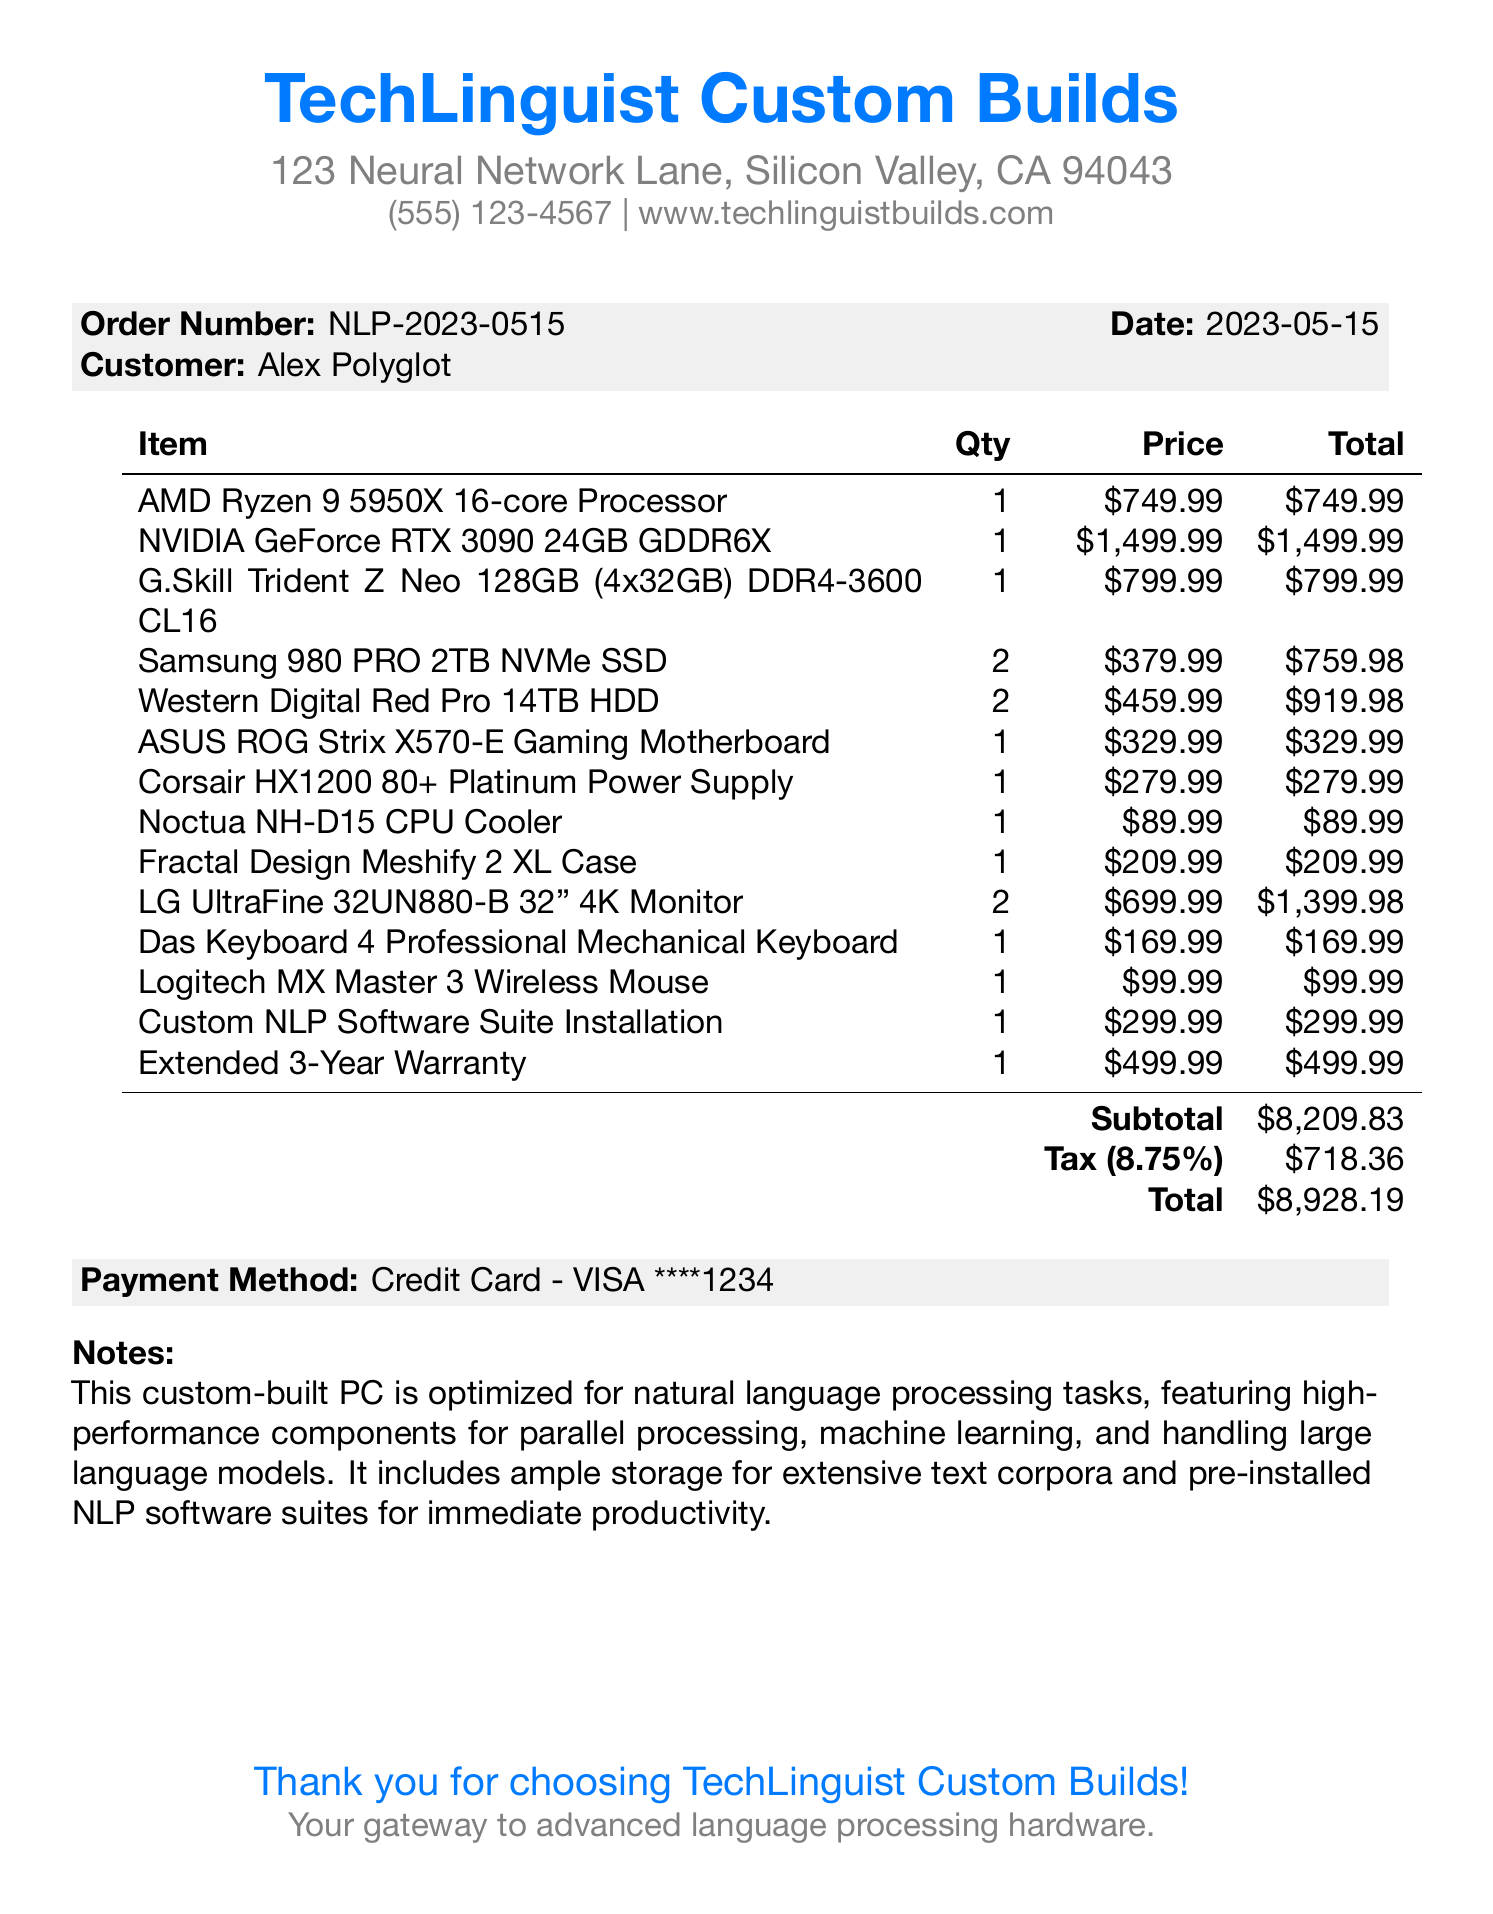What is the name of the store? The store name is listed at the top of the receipt.
Answer: TechLinguist Custom Builds What is the order number? The order number is mentioned in the order details section of the receipt.
Answer: NLP-2023-0515 How much did the AMD Ryzen 9 5950X cost? The price of the AMD Ryzen 9 5950X is specified in the item list.
Answer: $749.99 What is the quantity of NVIDIA GeForce RTX 3090 purchased? The quantity is indicated in the item list of the receipt.
Answer: 1 What is the total amount for the extended warranty? The total amount is included in the final totals section of the receipt.
Answer: $499.99 What is the total tax amount? The total tax amount is calculated based on the subtotal and tax rate provided.
Answer: $718.36 How many LG UltraFine monitors were ordered? The quantity of monitors is stated in the item list on the receipt.
Answer: 2 Which processor is optimized for parallel processing in NLP tasks? The description of the processor in the item list indicates its optimization for NLP tasks.
Answer: AMD Ryzen 9 5950X 16-core Processor How many storage devices are included in the custom-built PC? The receipt lists both SSDs and HDDs, which can be counted for a total.
Answer: 4 